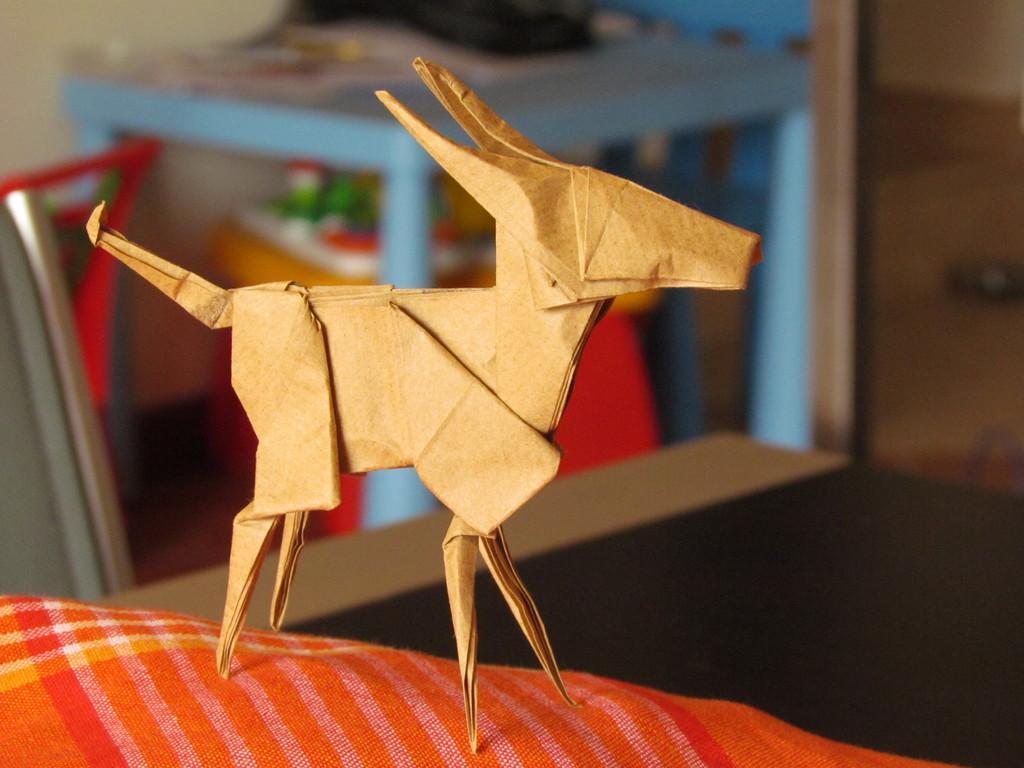Can you describe this image briefly? In this image I see the paper art and I see that the paper is of light brown in color and it is on a cloth which is of orange and red in color and it is blurred in the background and it is a bit dark over here and I see the blue color thing over here. 